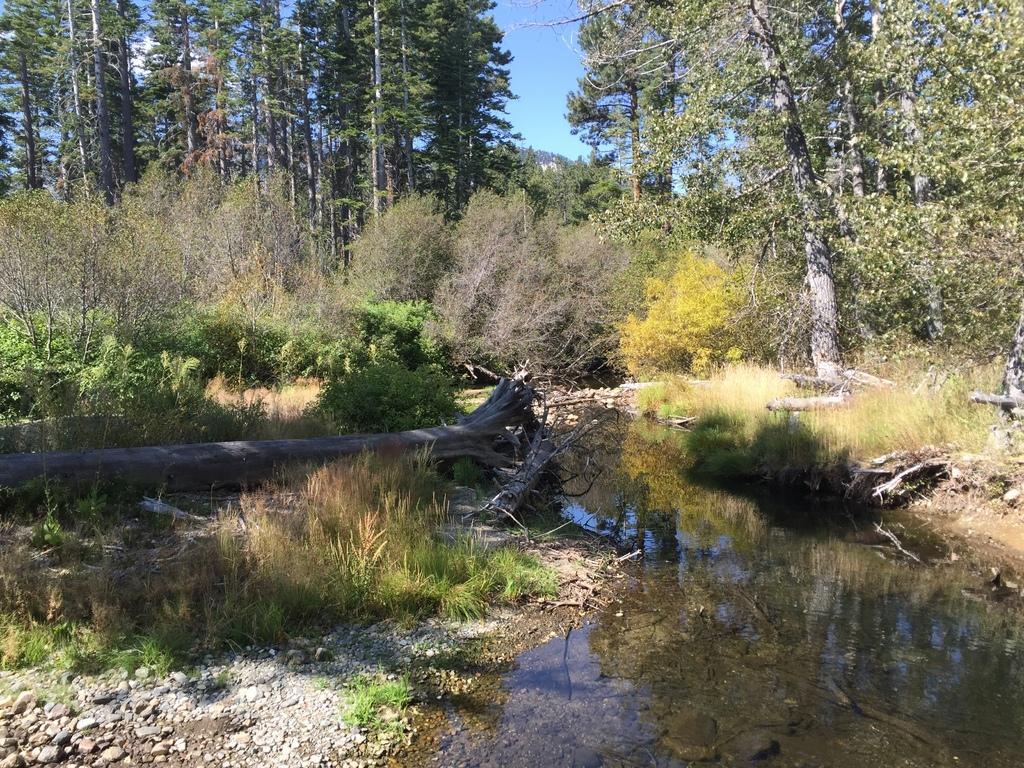Can you describe this image briefly? In this image, we can see trees and plants. At the bottom, there is water and twigs. At the top, there is sky. 